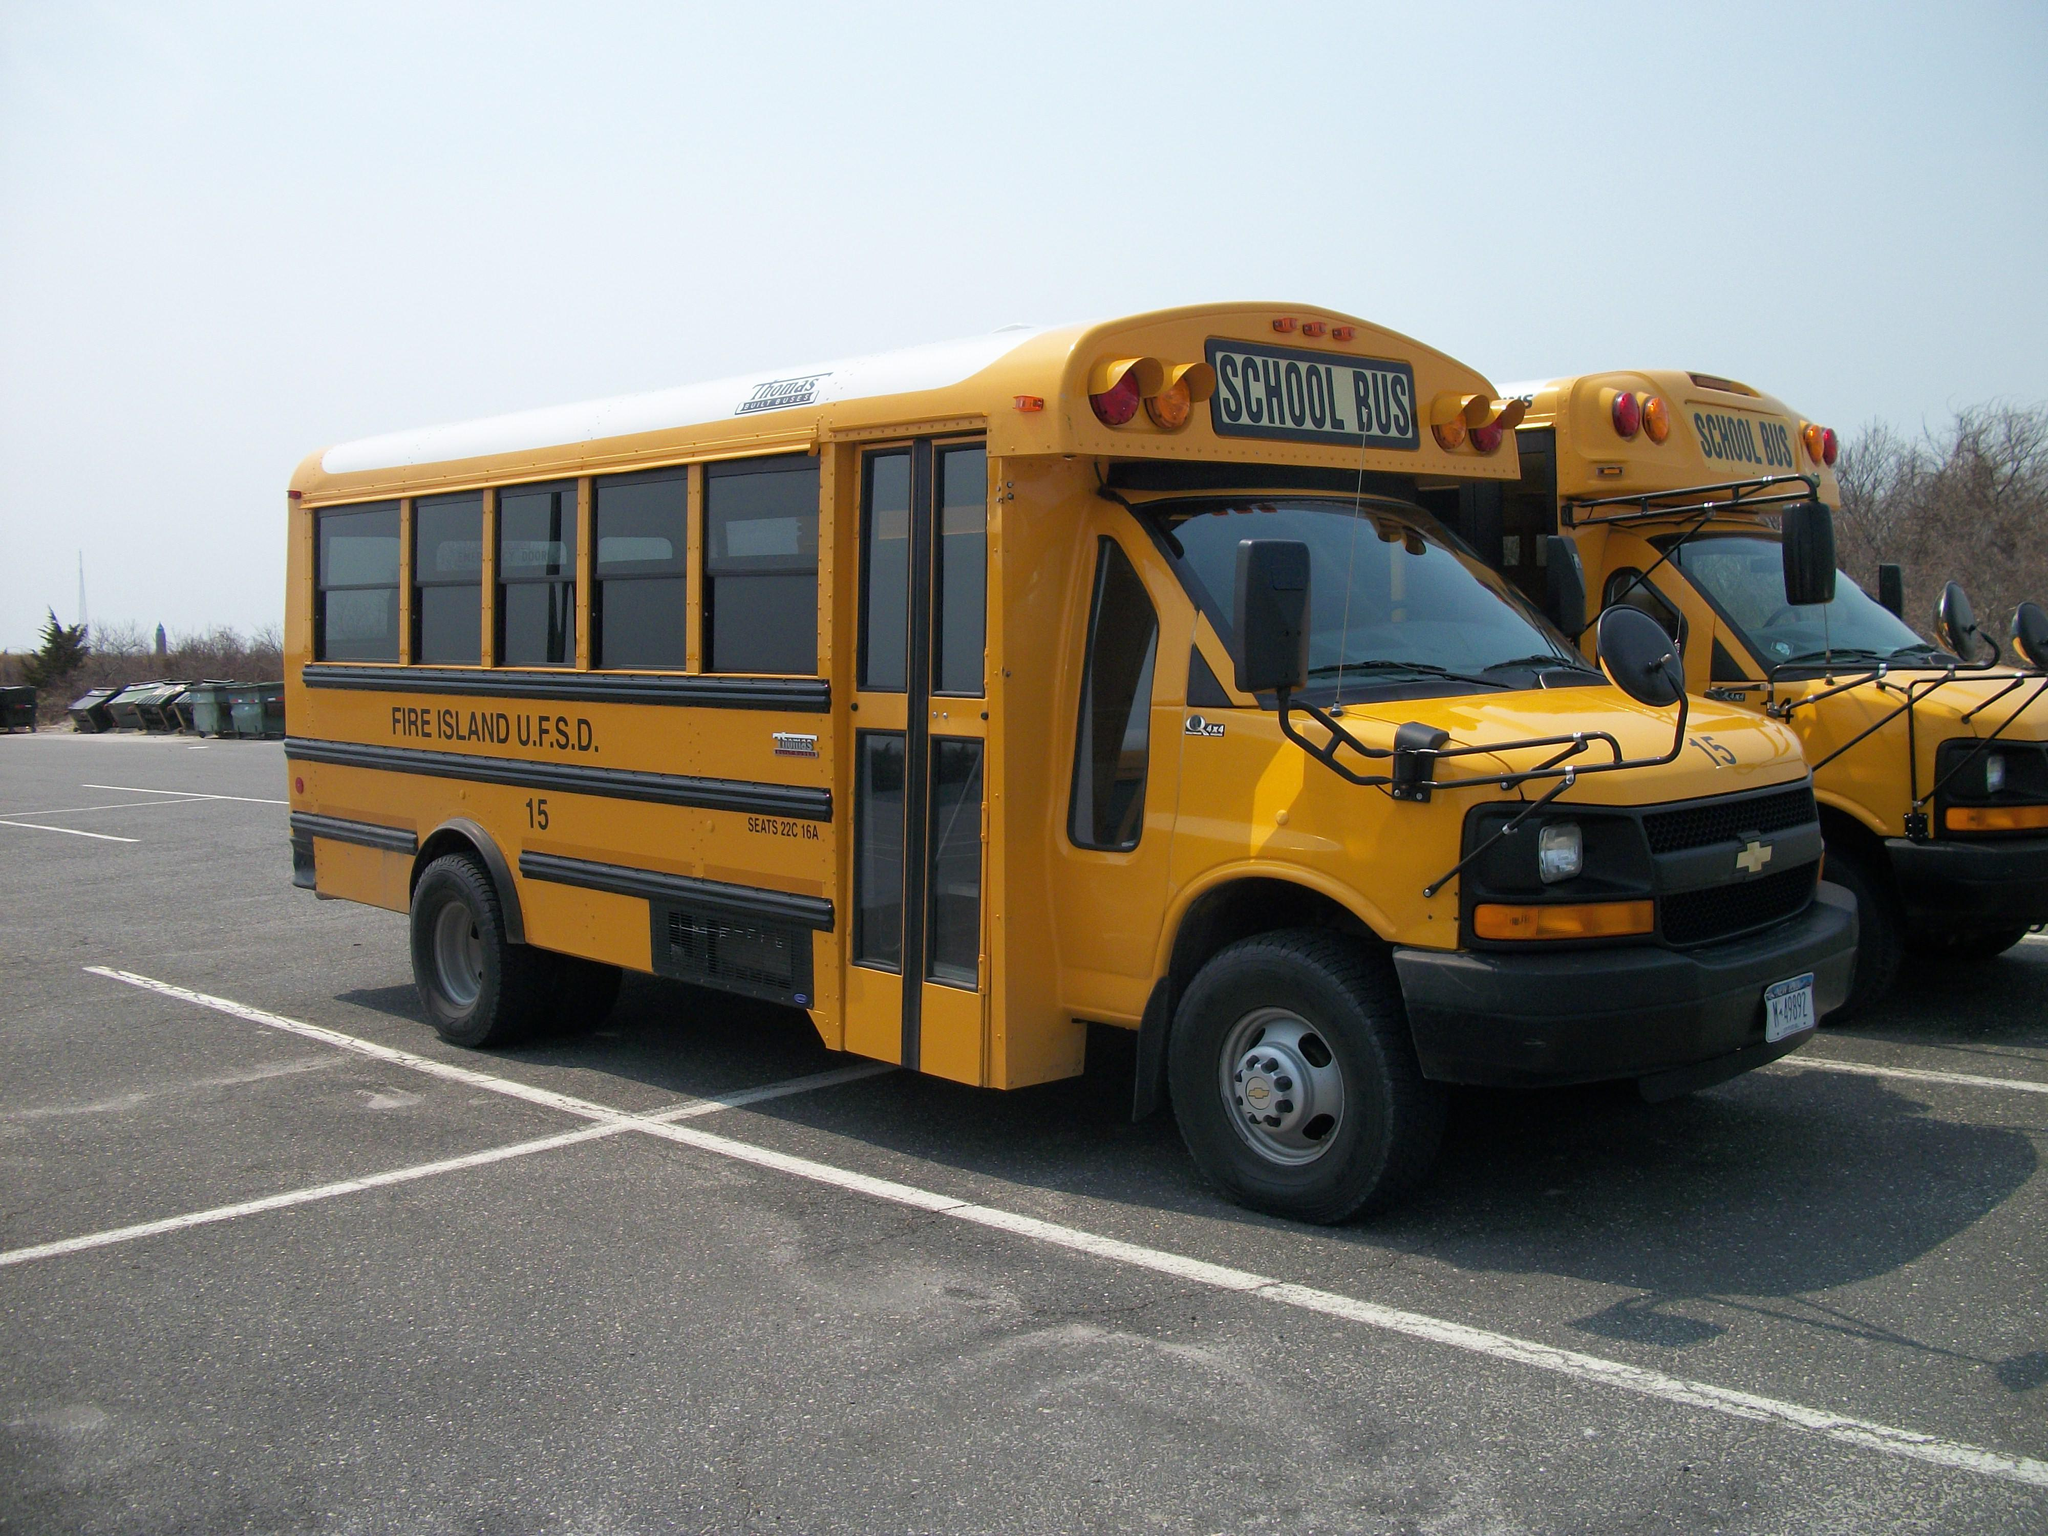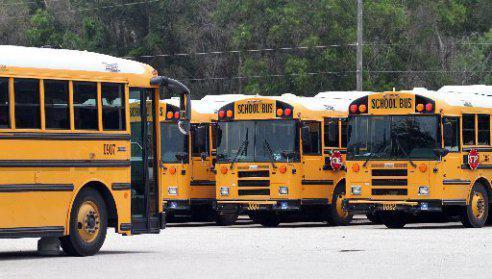The first image is the image on the left, the second image is the image on the right. For the images displayed, is the sentence "In the right image, a rightward-facing yellow bus appears to be colliding with something else that is yellow." factually correct? Answer yes or no. No. 